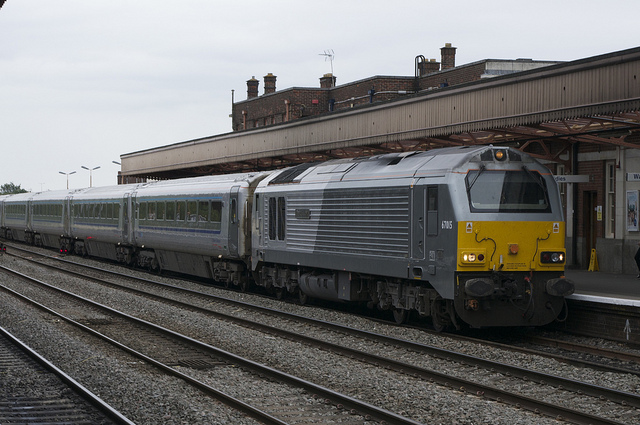What type of train is shown in the image? The image features a diesel-electric locomotive, identifiable by its robust design and the diesel array on the undercarriage. This kind of train is typically used for long-distance travel and can carry a substantial number of passengers or freight. 